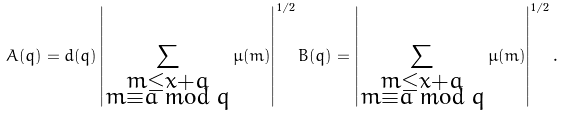<formula> <loc_0><loc_0><loc_500><loc_500>A ( q ) = d ( q ) \left | \sum _ { \substack { m \leq x + a \\ m \equiv a \bmod q } } \mu ( m ) \right | ^ { 1 / 2 } B ( q ) = \left | \sum _ { \substack { m \leq x + a \\ m \equiv a \bmod q } } \mu ( m ) \right | ^ { 1 / 2 } .</formula> 